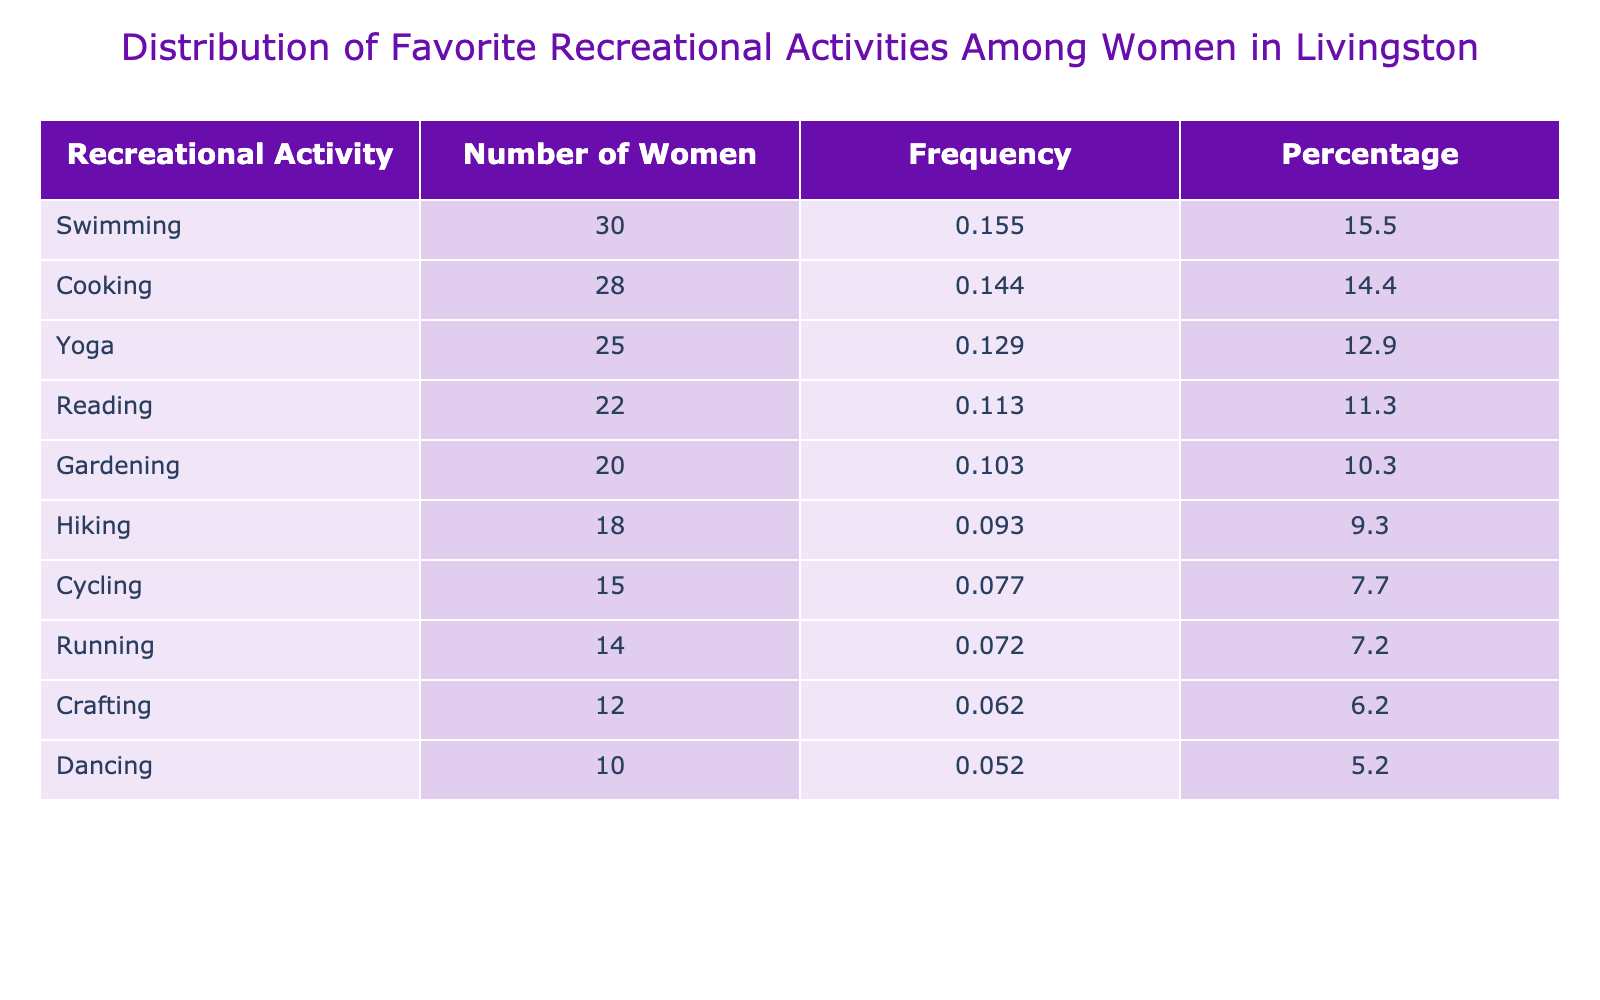What is the most popular recreational activity among women in Livingston? The table shows that Swimming has the highest number of women participating, with a total of 30 women.
Answer: Swimming How many women prefer Yoga? According to the table, 25 women indicated Yoga as their favorite recreational activity.
Answer: 25 What is the frequency percentage of Gardening? The number of women who chose Gardening is 20. The total number of women is 25 + 18 + 15 + 30 + 20 + 22 + 28 + 10 + 14 + 12 =  189. Therefore, the frequency percentage for Gardening is (20 / 189) * 100 ≈ 10.6%.
Answer: 10.6% Is Reading more popular than Crafting among women in Livingston? From the table, 22 women prefer Reading while 12 prefer Crafting. Therefore, Reading is more popular as it has a higher number of women choosing it.
Answer: Yes What is the total number of women who prefer Dancing and Running combined? To find the total, add the number of women who prefer Dancing (10) to the number who prefer Running (14). Thus, 10 + 14 = 24.
Answer: 24 What is the average number of women who chose each recreational activity? The total number of women across all activities is 189 (calculated previously). There are 10 activities listed. Therefore, the average is 189 / 10 = 18.9.
Answer: 18.9 Which recreational activity has the least number of participants? According to the table, Dancing has the least number of participants, with only 10 women choosing it.
Answer: Dancing How many more women prefer Cooking than Cycling? From the table, Cooking has 28 women and Cycling has 15 women. The difference is 28 - 15 = 13.
Answer: 13 Is there a recreational activity that exactly 15 women prefer? Looking at the table, Cycling is the activity that has exactly 15 women preferring it.
Answer: Yes 